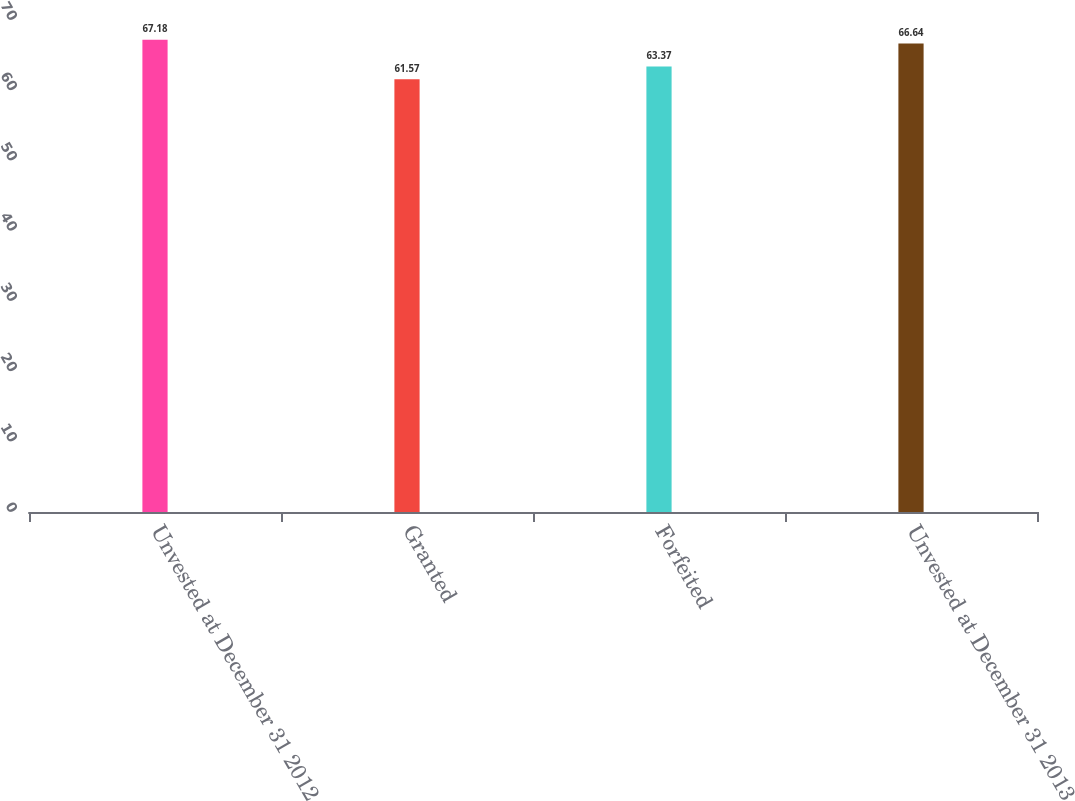Convert chart to OTSL. <chart><loc_0><loc_0><loc_500><loc_500><bar_chart><fcel>Unvested at December 31 2012<fcel>Granted<fcel>Forfeited<fcel>Unvested at December 31 2013<nl><fcel>67.18<fcel>61.57<fcel>63.37<fcel>66.64<nl></chart> 